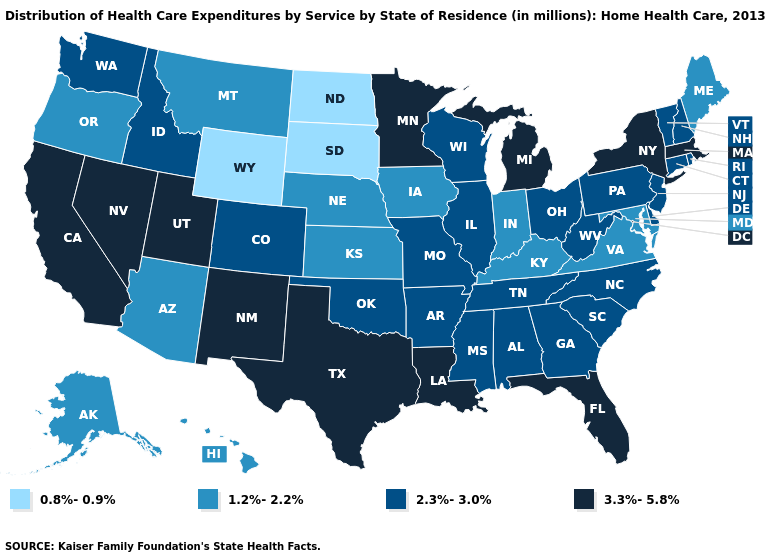Name the states that have a value in the range 2.3%-3.0%?
Write a very short answer. Alabama, Arkansas, Colorado, Connecticut, Delaware, Georgia, Idaho, Illinois, Mississippi, Missouri, New Hampshire, New Jersey, North Carolina, Ohio, Oklahoma, Pennsylvania, Rhode Island, South Carolina, Tennessee, Vermont, Washington, West Virginia, Wisconsin. Does Utah have a lower value than Oregon?
Answer briefly. No. Does Oklahoma have the lowest value in the USA?
Give a very brief answer. No. What is the lowest value in states that border Kentucky?
Quick response, please. 1.2%-2.2%. Is the legend a continuous bar?
Quick response, please. No. Is the legend a continuous bar?
Answer briefly. No. What is the value of New Jersey?
Give a very brief answer. 2.3%-3.0%. What is the lowest value in the Northeast?
Concise answer only. 1.2%-2.2%. Name the states that have a value in the range 0.8%-0.9%?
Quick response, please. North Dakota, South Dakota, Wyoming. What is the value of Nevada?
Be succinct. 3.3%-5.8%. Name the states that have a value in the range 1.2%-2.2%?
Be succinct. Alaska, Arizona, Hawaii, Indiana, Iowa, Kansas, Kentucky, Maine, Maryland, Montana, Nebraska, Oregon, Virginia. What is the value of Georgia?
Write a very short answer. 2.3%-3.0%. Name the states that have a value in the range 2.3%-3.0%?
Short answer required. Alabama, Arkansas, Colorado, Connecticut, Delaware, Georgia, Idaho, Illinois, Mississippi, Missouri, New Hampshire, New Jersey, North Carolina, Ohio, Oklahoma, Pennsylvania, Rhode Island, South Carolina, Tennessee, Vermont, Washington, West Virginia, Wisconsin. What is the highest value in the MidWest ?
Give a very brief answer. 3.3%-5.8%. 